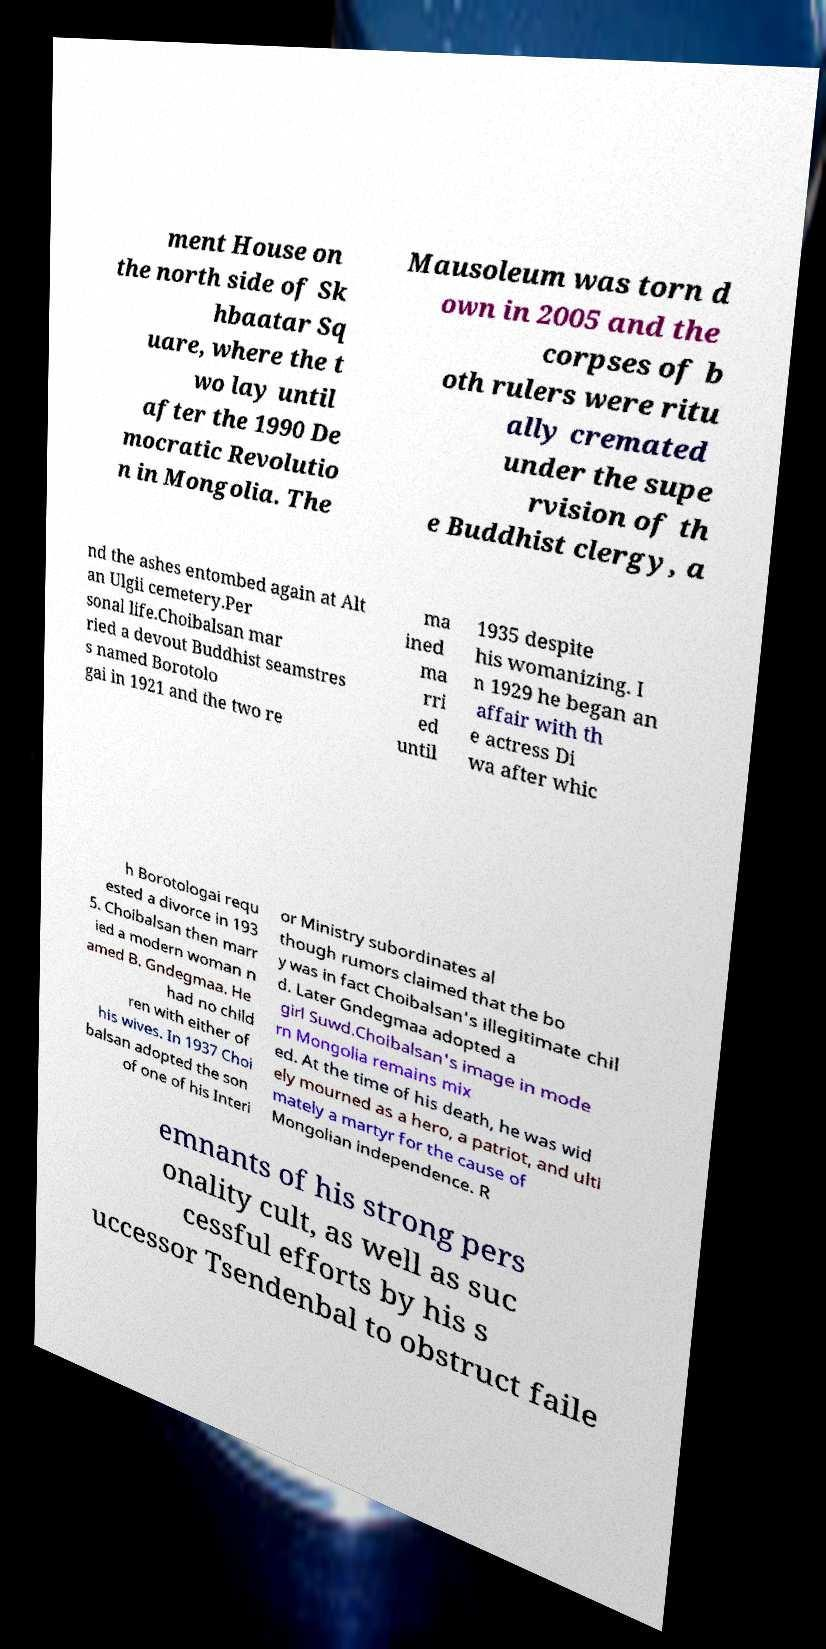Could you extract and type out the text from this image? ment House on the north side of Sk hbaatar Sq uare, where the t wo lay until after the 1990 De mocratic Revolutio n in Mongolia. The Mausoleum was torn d own in 2005 and the corpses of b oth rulers were ritu ally cremated under the supe rvision of th e Buddhist clergy, a nd the ashes entombed again at Alt an Ulgii cemetery.Per sonal life.Choibalsan mar ried a devout Buddhist seamstres s named Borotolo gai in 1921 and the two re ma ined ma rri ed until 1935 despite his womanizing. I n 1929 he began an affair with th e actress Di wa after whic h Borotologai requ ested a divorce in 193 5. Choibalsan then marr ied a modern woman n amed B. Gndegmaa. He had no child ren with either of his wives. In 1937 Choi balsan adopted the son of one of his Interi or Ministry subordinates al though rumors claimed that the bo y was in fact Choibalsan's illegitimate chil d. Later Gndegmaa adopted a girl Suwd.Choibalsan's image in mode rn Mongolia remains mix ed. At the time of his death, he was wid ely mourned as a hero, a patriot, and ulti mately a martyr for the cause of Mongolian independence. R emnants of his strong pers onality cult, as well as suc cessful efforts by his s uccessor Tsendenbal to obstruct faile 